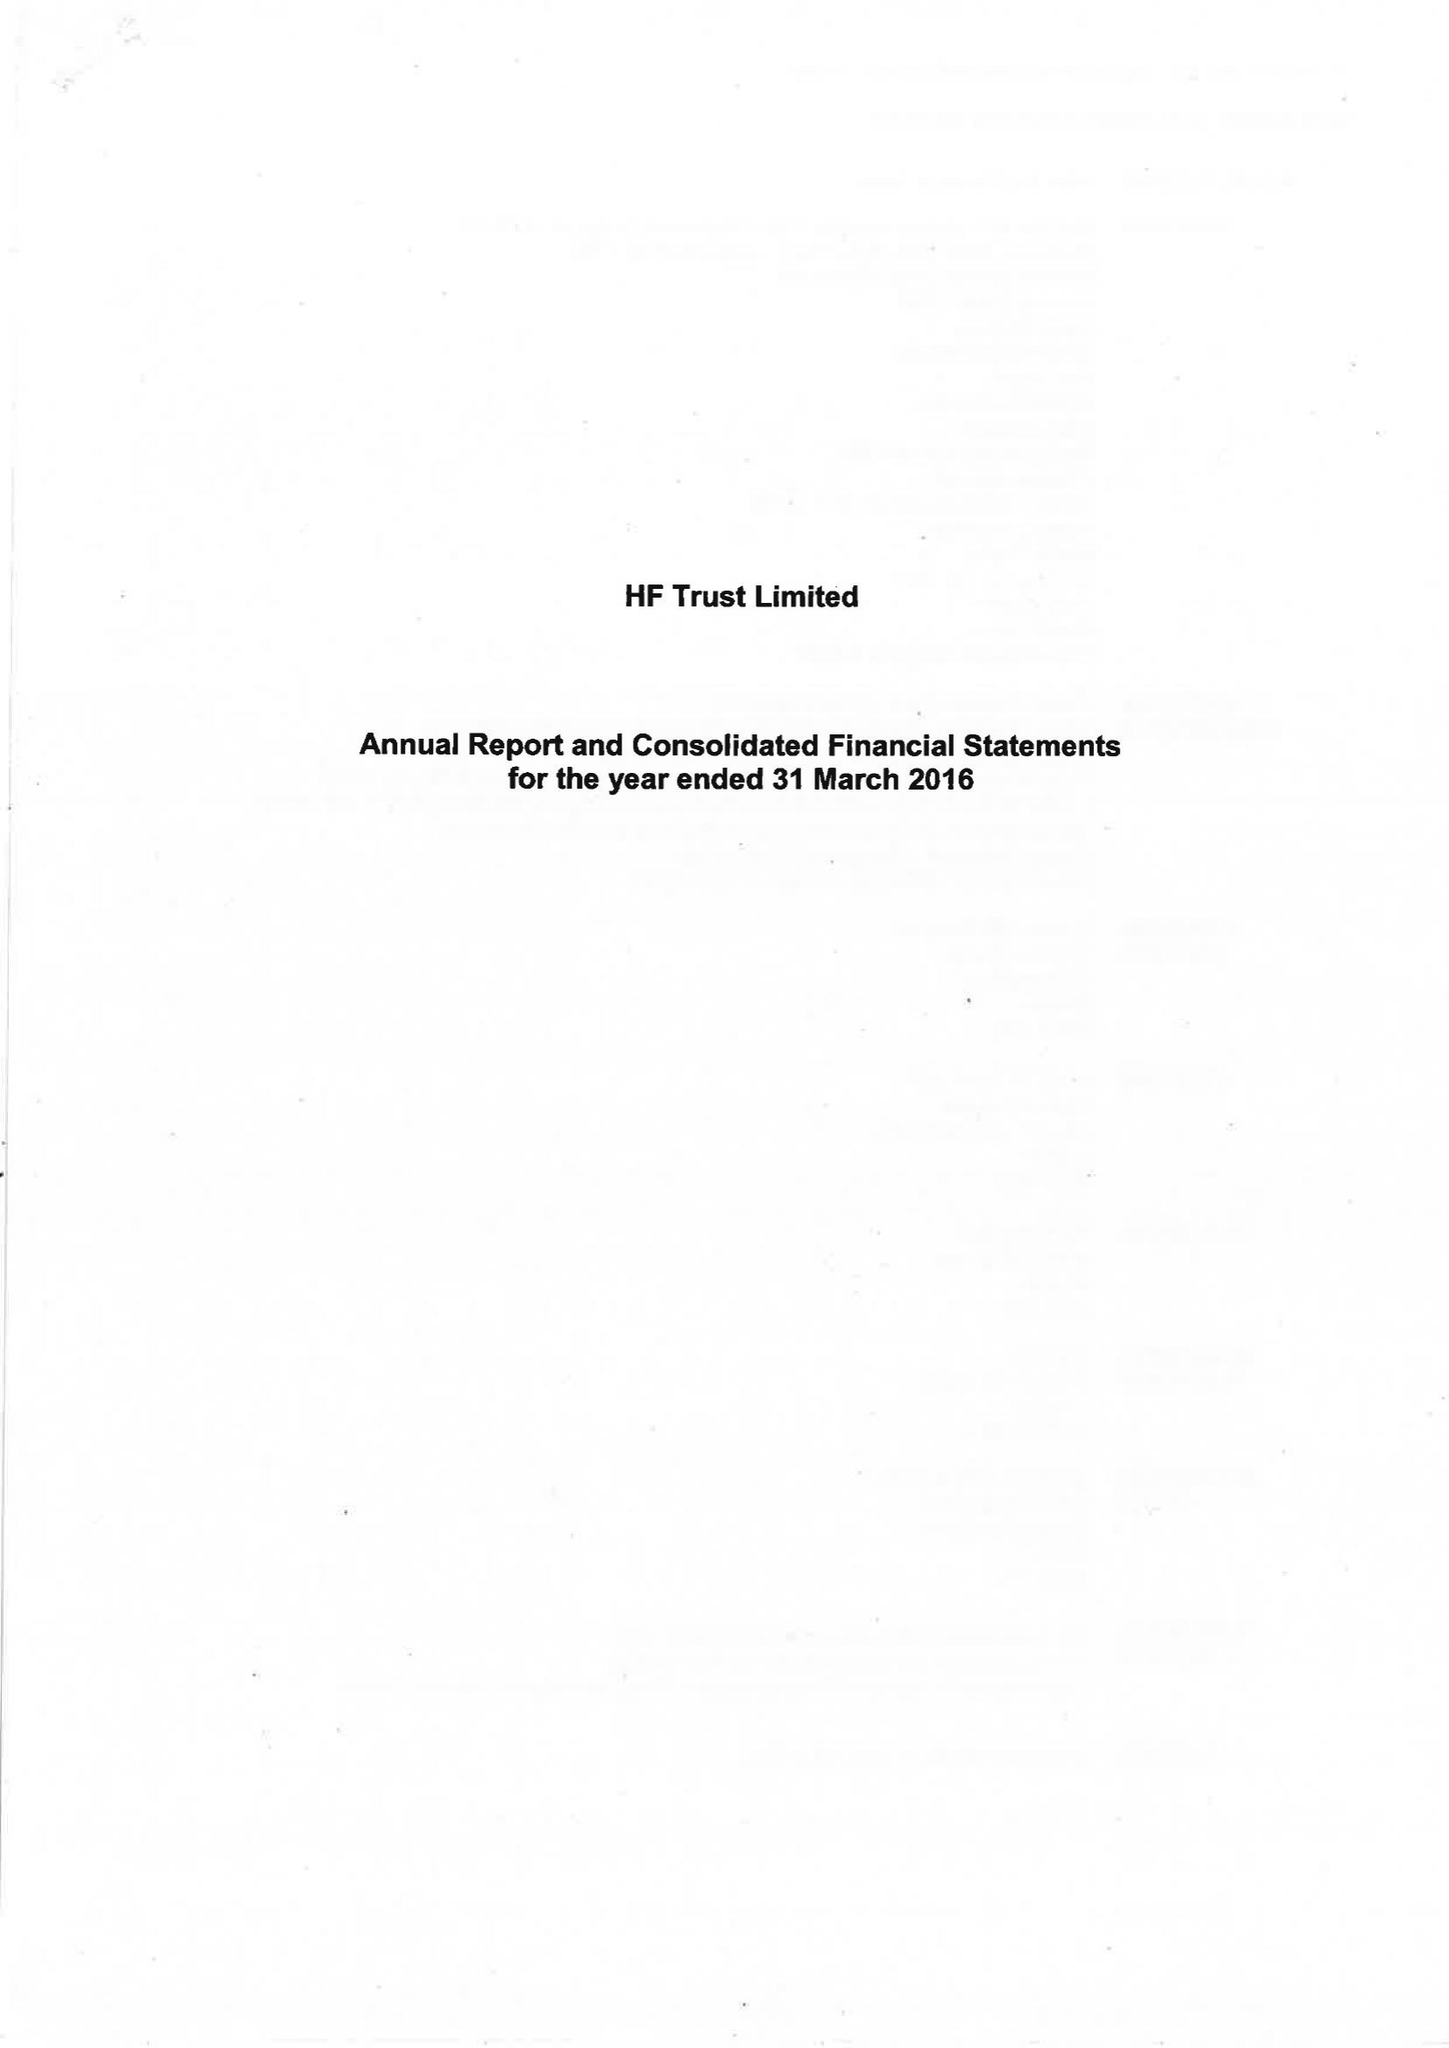What is the value for the address__street_line?
Answer the question using a single word or phrase. None 